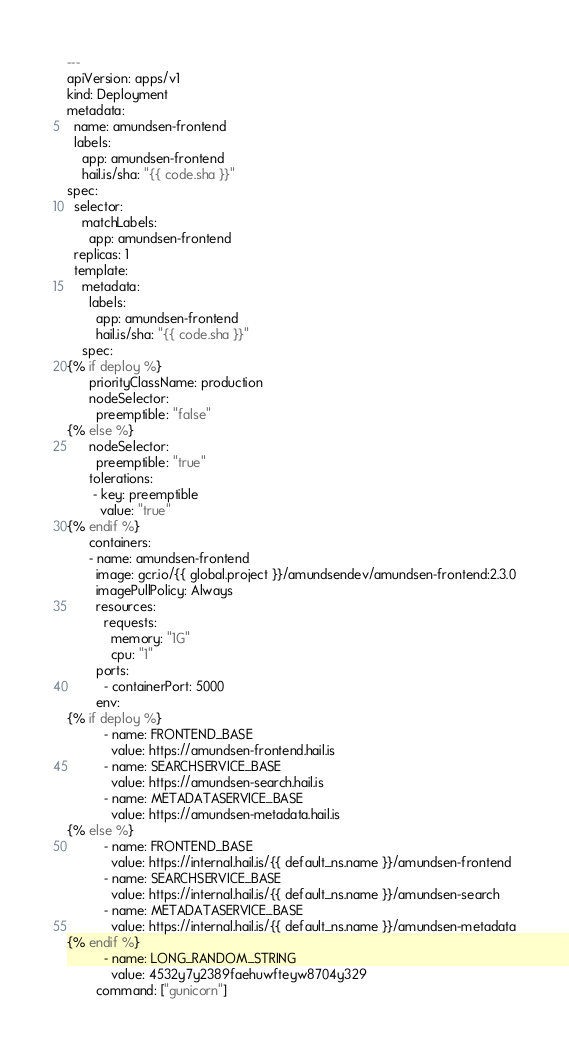<code> <loc_0><loc_0><loc_500><loc_500><_YAML_>---
apiVersion: apps/v1
kind: Deployment
metadata:
  name: amundsen-frontend
  labels:
    app: amundsen-frontend
    hail.is/sha: "{{ code.sha }}"
spec:
  selector:
    matchLabels:
      app: amundsen-frontend
  replicas: 1
  template:
    metadata:
      labels:
        app: amundsen-frontend
        hail.is/sha: "{{ code.sha }}"
    spec:
{% if deploy %}
      priorityClassName: production
      nodeSelector:
        preemptible: "false"
{% else %}
      nodeSelector:
        preemptible: "true"
      tolerations:
       - key: preemptible
         value: "true"
{% endif %}
      containers:
      - name: amundsen-frontend
        image: gcr.io/{{ global.project }}/amundsendev/amundsen-frontend:2.3.0
        imagePullPolicy: Always
        resources:
          requests:
            memory: "1G"
            cpu: "1"
        ports:
          - containerPort: 5000
        env:
{% if deploy %}
          - name: FRONTEND_BASE
            value: https://amundsen-frontend.hail.is
          - name: SEARCHSERVICE_BASE
            value: https://amundsen-search.hail.is
          - name: METADATASERVICE_BASE
            value: https://amundsen-metadata.hail.is
{% else %}
          - name: FRONTEND_BASE
            value: https://internal.hail.is/{{ default_ns.name }}/amundsen-frontend
          - name: SEARCHSERVICE_BASE
            value: https://internal.hail.is/{{ default_ns.name }}/amundsen-search
          - name: METADATASERVICE_BASE
            value: https://internal.hail.is/{{ default_ns.name }}/amundsen-metadata
{% endif %}
          - name: LONG_RANDOM_STRING
            value: 4532y7y2389faehuwfteyw8704y329
        command: ["gunicorn"]</code> 